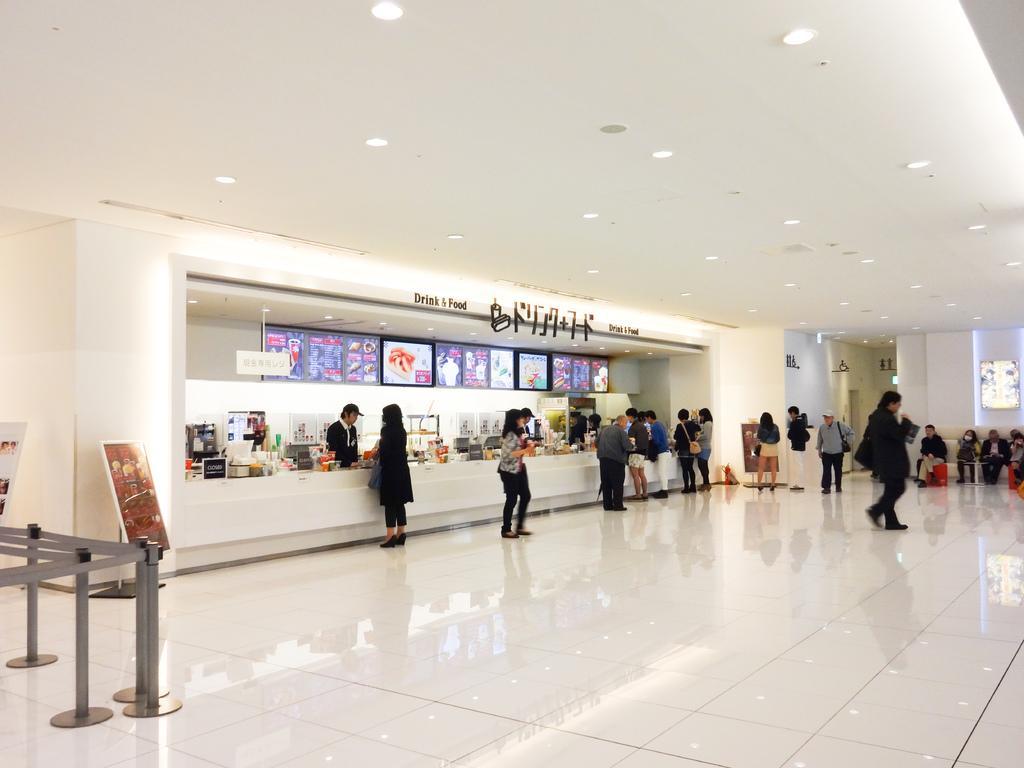Can you describe this image briefly? This is an inside view of a building and here we can see people and some are wearing bags and some other are sitting on the sofa. In the background, there are boards, stands with ribbons and there are screens, posters and some other objects in the store. At the top, there are lights and at the bottom, there is a floor. 